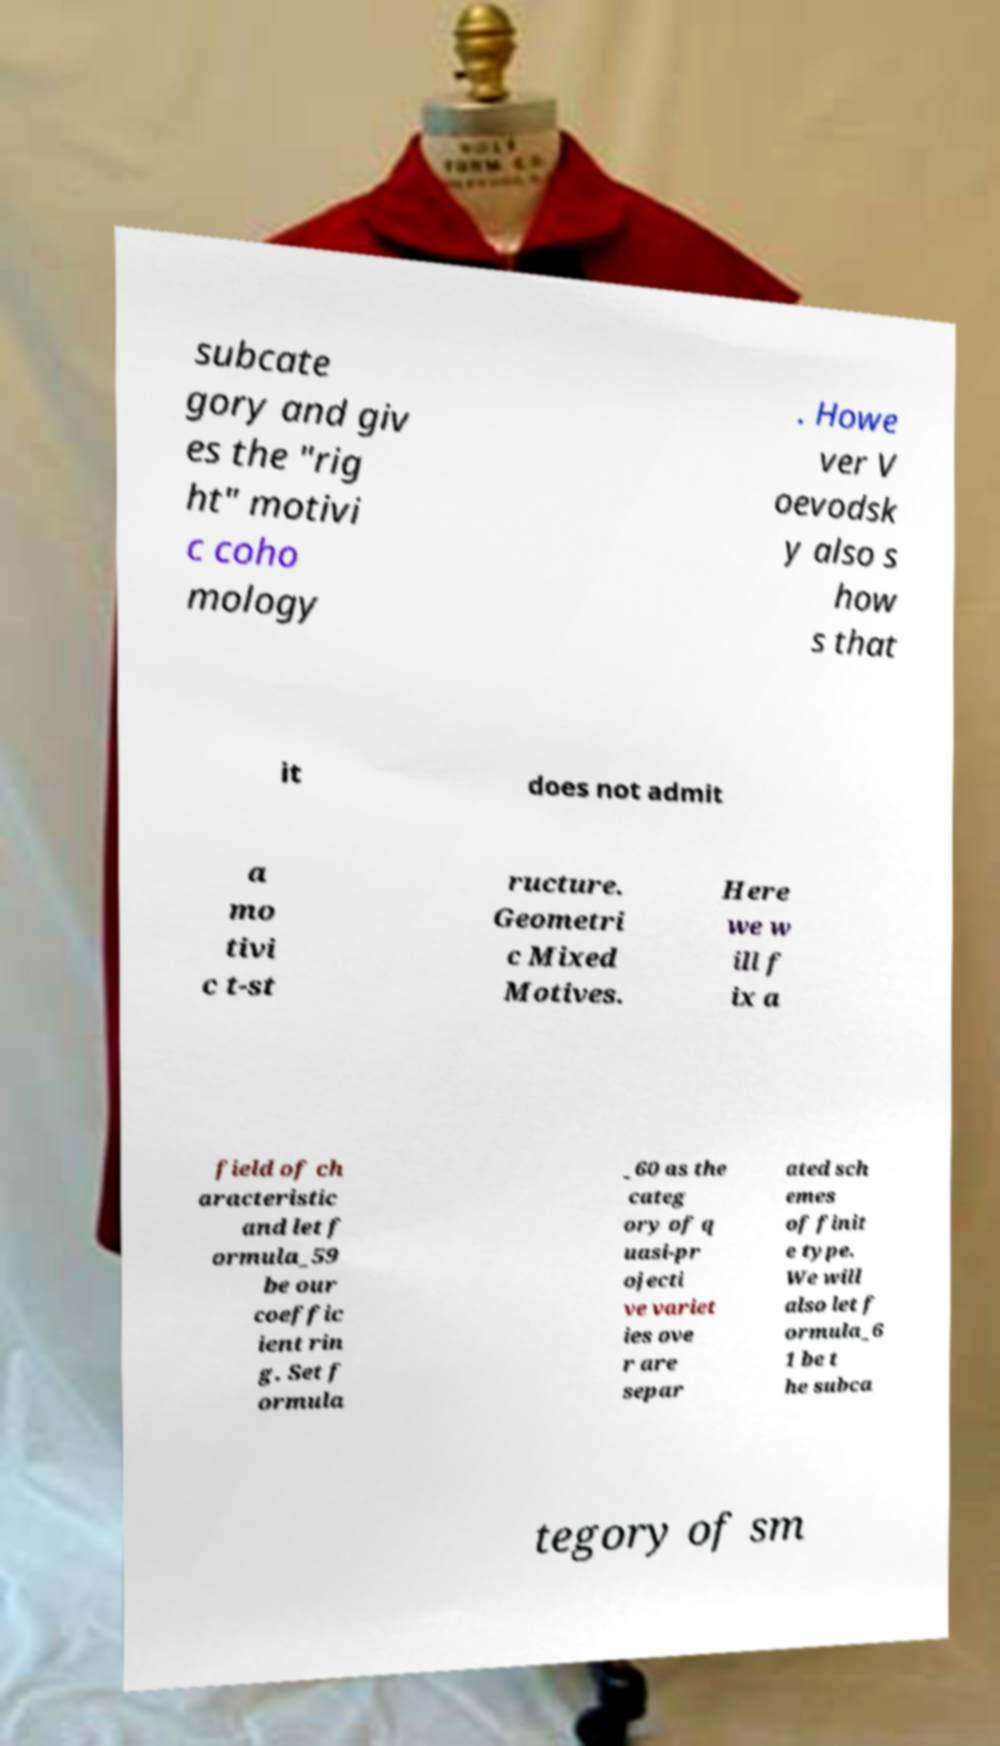I need the written content from this picture converted into text. Can you do that? subcate gory and giv es the "rig ht" motivi c coho mology . Howe ver V oevodsk y also s how s that it does not admit a mo tivi c t-st ructure. Geometri c Mixed Motives. Here we w ill f ix a field of ch aracteristic and let f ormula_59 be our coeffic ient rin g. Set f ormula _60 as the categ ory of q uasi-pr ojecti ve variet ies ove r are separ ated sch emes of finit e type. We will also let f ormula_6 1 be t he subca tegory of sm 